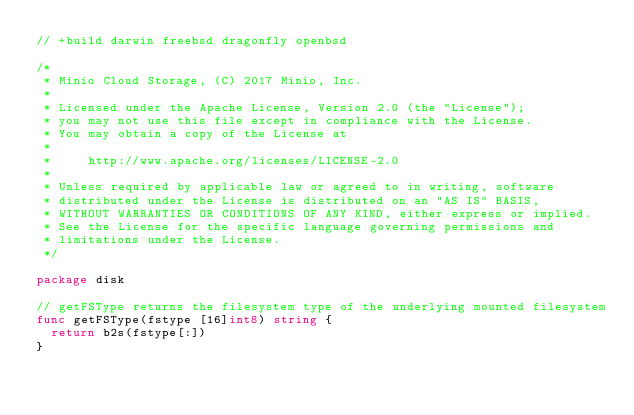Convert code to text. <code><loc_0><loc_0><loc_500><loc_500><_Go_>// +build darwin freebsd dragonfly openbsd

/*
 * Minio Cloud Storage, (C) 2017 Minio, Inc.
 *
 * Licensed under the Apache License, Version 2.0 (the "License");
 * you may not use this file except in compliance with the License.
 * You may obtain a copy of the License at
 *
 *     http://www.apache.org/licenses/LICENSE-2.0
 *
 * Unless required by applicable law or agreed to in writing, software
 * distributed under the License is distributed on an "AS IS" BASIS,
 * WITHOUT WARRANTIES OR CONDITIONS OF ANY KIND, either express or implied.
 * See the License for the specific language governing permissions and
 * limitations under the License.
 */

package disk

// getFSType returns the filesystem type of the underlying mounted filesystem
func getFSType(fstype [16]int8) string {
	return b2s(fstype[:])
}
</code> 